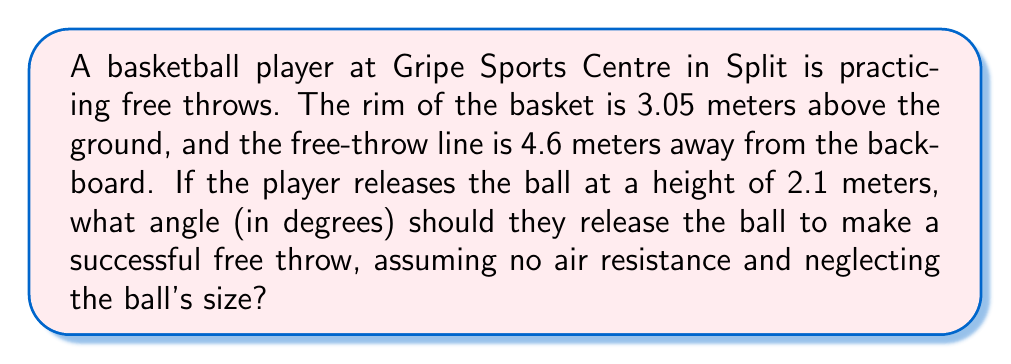Teach me how to tackle this problem. Let's approach this step-by-step:

1) First, we need to visualize the problem. The path of the ball forms a right triangle:
   - The horizontal distance is 4.6 m
   - The vertical distance is the difference between the rim height and release height:
     3.05 m - 2.1 m = 0.95 m

2) We can represent this scenario using Asymptote:

[asy]
import geometry;

unitsize(1cm);

pair A = (0,0);
pair B = (4.6,0);
pair C = (4.6,0.95);

draw(A--B--C--A);

label("4.6 m", (2.3,-0.3));
label("0.95 m", (4.9,0.475));
label("θ", (0.3,0.1));

draw(arc(A,0.5,0,atan2(0.95,4.6)*180/pi), Arrow);
[/asy]

3) Now, we need to find the angle θ at which the ball should be released.

4) We can use the tangent function to find this angle:

   $$\tan(\theta) = \frac{\text{opposite}}{\text{adjacent}} = \frac{0.95}{4.6}$$

5) To solve for θ, we use the inverse tangent (arctangent) function:

   $$\theta = \arctan(\frac{0.95}{4.6})$$

6) Calculate this value:
   $$\theta = \arctan(0.2065) \approx 11.67°$$

7) Round to two decimal places for the final answer.
Answer: $11.67°$ 